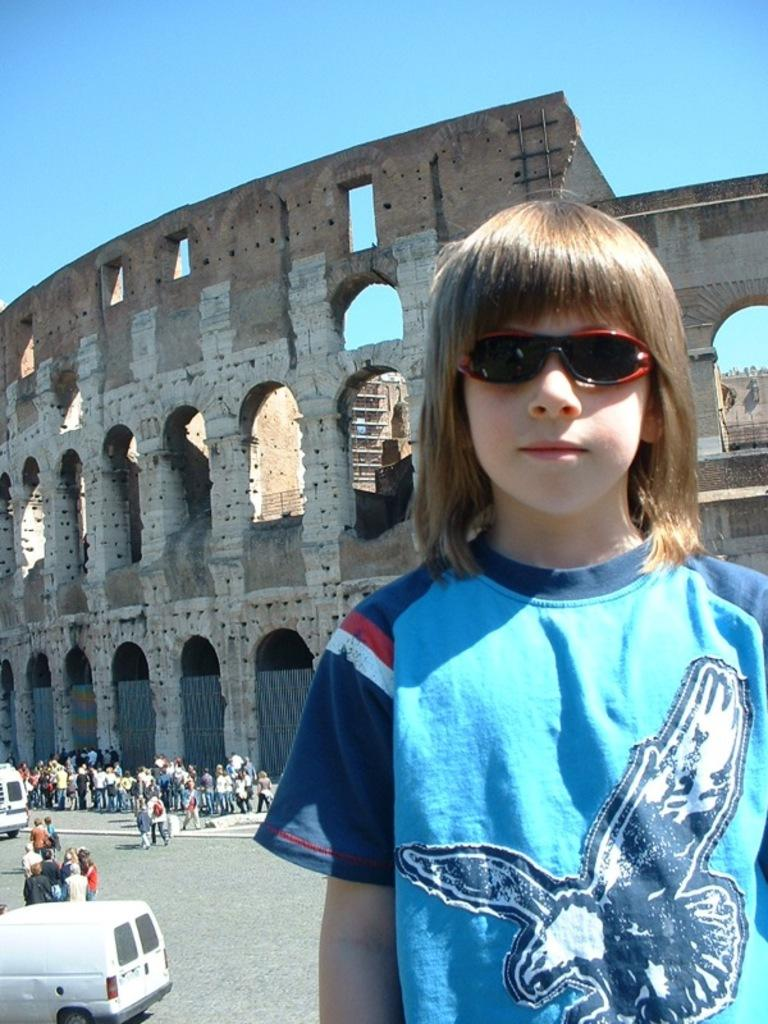What can be seen in the image involving people? There are people standing in the image. What else is visible on the road in the image? There are vehicles on the road in the image. Can you describe the old building in the image? There is an old building in the image. What is the person wearing in the image? A person is standing with sunglasses in the image. What color is the sky in the image? The sky is blue in the image. What type of wood is being destroyed by the gold in the image? There is no wood, destruction, or gold present in the image. 